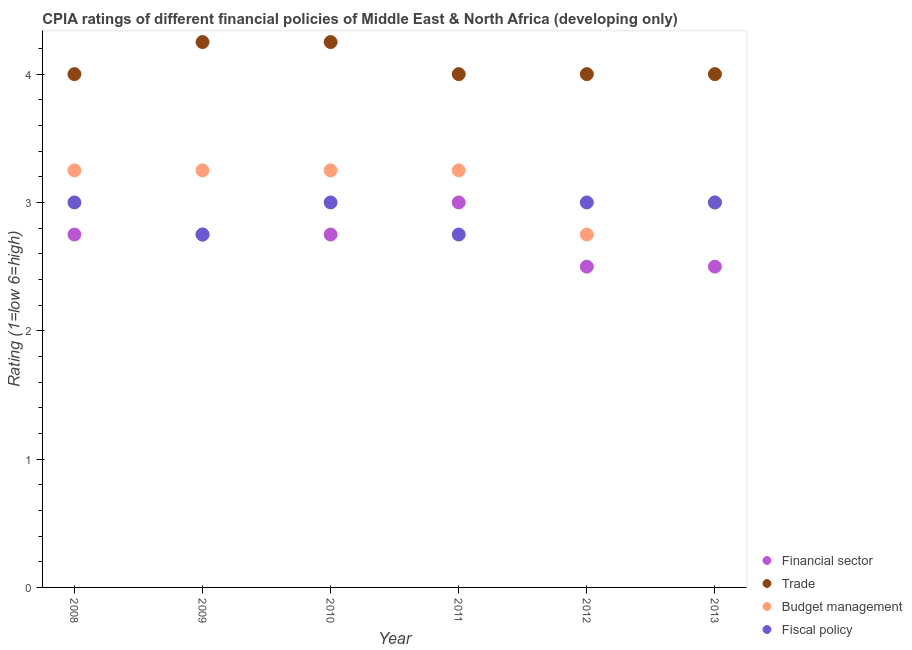Is the number of dotlines equal to the number of legend labels?
Offer a terse response. Yes. Across all years, what is the maximum cpia rating of trade?
Your answer should be compact. 4.25. Across all years, what is the minimum cpia rating of trade?
Your answer should be compact. 4. What is the total cpia rating of fiscal policy in the graph?
Provide a short and direct response. 17.5. What is the average cpia rating of financial sector per year?
Offer a terse response. 2.71. Is the cpia rating of budget management in 2009 less than that in 2013?
Offer a very short reply. No. Is the difference between the cpia rating of financial sector in 2009 and 2010 greater than the difference between the cpia rating of fiscal policy in 2009 and 2010?
Your response must be concise. Yes. In how many years, is the cpia rating of trade greater than the average cpia rating of trade taken over all years?
Make the answer very short. 2. Is the sum of the cpia rating of budget management in 2008 and 2012 greater than the maximum cpia rating of fiscal policy across all years?
Your response must be concise. Yes. Is it the case that in every year, the sum of the cpia rating of trade and cpia rating of fiscal policy is greater than the sum of cpia rating of budget management and cpia rating of financial sector?
Your answer should be very brief. Yes. Is it the case that in every year, the sum of the cpia rating of financial sector and cpia rating of trade is greater than the cpia rating of budget management?
Keep it short and to the point. Yes. How many dotlines are there?
Ensure brevity in your answer.  4. How many years are there in the graph?
Provide a succinct answer. 6. What is the difference between two consecutive major ticks on the Y-axis?
Offer a very short reply. 1. Are the values on the major ticks of Y-axis written in scientific E-notation?
Offer a very short reply. No. Does the graph contain any zero values?
Your response must be concise. No. How are the legend labels stacked?
Your answer should be very brief. Vertical. What is the title of the graph?
Give a very brief answer. CPIA ratings of different financial policies of Middle East & North Africa (developing only). Does "Periodicity assessment" appear as one of the legend labels in the graph?
Your answer should be compact. No. What is the label or title of the X-axis?
Keep it short and to the point. Year. What is the Rating (1=low 6=high) in Financial sector in 2008?
Give a very brief answer. 2.75. What is the Rating (1=low 6=high) in Trade in 2008?
Provide a short and direct response. 4. What is the Rating (1=low 6=high) of Budget management in 2008?
Offer a very short reply. 3.25. What is the Rating (1=low 6=high) of Fiscal policy in 2008?
Keep it short and to the point. 3. What is the Rating (1=low 6=high) of Financial sector in 2009?
Your answer should be compact. 2.75. What is the Rating (1=low 6=high) in Trade in 2009?
Offer a very short reply. 4.25. What is the Rating (1=low 6=high) of Fiscal policy in 2009?
Provide a short and direct response. 2.75. What is the Rating (1=low 6=high) of Financial sector in 2010?
Provide a succinct answer. 2.75. What is the Rating (1=low 6=high) in Trade in 2010?
Keep it short and to the point. 4.25. What is the Rating (1=low 6=high) of Financial sector in 2011?
Your response must be concise. 3. What is the Rating (1=low 6=high) of Budget management in 2011?
Make the answer very short. 3.25. What is the Rating (1=low 6=high) of Fiscal policy in 2011?
Give a very brief answer. 2.75. What is the Rating (1=low 6=high) in Trade in 2012?
Offer a very short reply. 4. What is the Rating (1=low 6=high) of Budget management in 2012?
Provide a short and direct response. 2.75. What is the Rating (1=low 6=high) of Fiscal policy in 2012?
Your answer should be compact. 3. What is the Rating (1=low 6=high) in Budget management in 2013?
Provide a succinct answer. 3. Across all years, what is the maximum Rating (1=low 6=high) of Trade?
Provide a short and direct response. 4.25. Across all years, what is the maximum Rating (1=low 6=high) of Fiscal policy?
Give a very brief answer. 3. Across all years, what is the minimum Rating (1=low 6=high) of Financial sector?
Provide a short and direct response. 2.5. Across all years, what is the minimum Rating (1=low 6=high) in Trade?
Give a very brief answer. 4. Across all years, what is the minimum Rating (1=low 6=high) of Budget management?
Keep it short and to the point. 2.75. Across all years, what is the minimum Rating (1=low 6=high) of Fiscal policy?
Provide a short and direct response. 2.75. What is the total Rating (1=low 6=high) in Financial sector in the graph?
Ensure brevity in your answer.  16.25. What is the total Rating (1=low 6=high) in Trade in the graph?
Offer a terse response. 24.5. What is the total Rating (1=low 6=high) of Budget management in the graph?
Keep it short and to the point. 18.75. What is the difference between the Rating (1=low 6=high) of Financial sector in 2008 and that in 2009?
Keep it short and to the point. 0. What is the difference between the Rating (1=low 6=high) of Trade in 2008 and that in 2009?
Your answer should be very brief. -0.25. What is the difference between the Rating (1=low 6=high) in Fiscal policy in 2008 and that in 2009?
Your response must be concise. 0.25. What is the difference between the Rating (1=low 6=high) of Trade in 2008 and that in 2010?
Offer a terse response. -0.25. What is the difference between the Rating (1=low 6=high) in Fiscal policy in 2008 and that in 2010?
Provide a succinct answer. 0. What is the difference between the Rating (1=low 6=high) of Financial sector in 2008 and that in 2011?
Provide a short and direct response. -0.25. What is the difference between the Rating (1=low 6=high) in Trade in 2008 and that in 2011?
Provide a short and direct response. 0. What is the difference between the Rating (1=low 6=high) in Budget management in 2008 and that in 2011?
Your answer should be very brief. 0. What is the difference between the Rating (1=low 6=high) of Budget management in 2008 and that in 2012?
Ensure brevity in your answer.  0.5. What is the difference between the Rating (1=low 6=high) of Financial sector in 2008 and that in 2013?
Offer a very short reply. 0.25. What is the difference between the Rating (1=low 6=high) in Fiscal policy in 2008 and that in 2013?
Your answer should be very brief. 0. What is the difference between the Rating (1=low 6=high) in Financial sector in 2009 and that in 2010?
Make the answer very short. 0. What is the difference between the Rating (1=low 6=high) in Budget management in 2009 and that in 2010?
Give a very brief answer. 0. What is the difference between the Rating (1=low 6=high) in Fiscal policy in 2009 and that in 2010?
Offer a very short reply. -0.25. What is the difference between the Rating (1=low 6=high) of Financial sector in 2009 and that in 2011?
Your answer should be compact. -0.25. What is the difference between the Rating (1=low 6=high) in Trade in 2009 and that in 2011?
Your answer should be very brief. 0.25. What is the difference between the Rating (1=low 6=high) in Trade in 2009 and that in 2012?
Your answer should be very brief. 0.25. What is the difference between the Rating (1=low 6=high) in Financial sector in 2009 and that in 2013?
Provide a succinct answer. 0.25. What is the difference between the Rating (1=low 6=high) in Trade in 2009 and that in 2013?
Make the answer very short. 0.25. What is the difference between the Rating (1=low 6=high) in Budget management in 2009 and that in 2013?
Provide a succinct answer. 0.25. What is the difference between the Rating (1=low 6=high) of Fiscal policy in 2009 and that in 2013?
Provide a short and direct response. -0.25. What is the difference between the Rating (1=low 6=high) of Financial sector in 2010 and that in 2011?
Provide a short and direct response. -0.25. What is the difference between the Rating (1=low 6=high) in Trade in 2010 and that in 2011?
Offer a terse response. 0.25. What is the difference between the Rating (1=low 6=high) in Financial sector in 2010 and that in 2012?
Provide a short and direct response. 0.25. What is the difference between the Rating (1=low 6=high) of Trade in 2010 and that in 2012?
Make the answer very short. 0.25. What is the difference between the Rating (1=low 6=high) in Budget management in 2010 and that in 2012?
Keep it short and to the point. 0.5. What is the difference between the Rating (1=low 6=high) in Budget management in 2010 and that in 2013?
Your answer should be very brief. 0.25. What is the difference between the Rating (1=low 6=high) of Fiscal policy in 2010 and that in 2013?
Your answer should be very brief. 0. What is the difference between the Rating (1=low 6=high) of Budget management in 2011 and that in 2012?
Provide a succinct answer. 0.5. What is the difference between the Rating (1=low 6=high) in Fiscal policy in 2011 and that in 2012?
Your answer should be compact. -0.25. What is the difference between the Rating (1=low 6=high) in Financial sector in 2011 and that in 2013?
Your answer should be very brief. 0.5. What is the difference between the Rating (1=low 6=high) of Trade in 2011 and that in 2013?
Your answer should be compact. 0. What is the difference between the Rating (1=low 6=high) in Budget management in 2011 and that in 2013?
Keep it short and to the point. 0.25. What is the difference between the Rating (1=low 6=high) of Financial sector in 2012 and that in 2013?
Provide a succinct answer. 0. What is the difference between the Rating (1=low 6=high) in Trade in 2012 and that in 2013?
Offer a very short reply. 0. What is the difference between the Rating (1=low 6=high) of Budget management in 2012 and that in 2013?
Provide a succinct answer. -0.25. What is the difference between the Rating (1=low 6=high) of Financial sector in 2008 and the Rating (1=low 6=high) of Trade in 2009?
Keep it short and to the point. -1.5. What is the difference between the Rating (1=low 6=high) in Trade in 2008 and the Rating (1=low 6=high) in Budget management in 2009?
Ensure brevity in your answer.  0.75. What is the difference between the Rating (1=low 6=high) of Trade in 2008 and the Rating (1=low 6=high) of Budget management in 2010?
Ensure brevity in your answer.  0.75. What is the difference between the Rating (1=low 6=high) of Financial sector in 2008 and the Rating (1=low 6=high) of Trade in 2011?
Offer a terse response. -1.25. What is the difference between the Rating (1=low 6=high) of Financial sector in 2008 and the Rating (1=low 6=high) of Budget management in 2011?
Offer a very short reply. -0.5. What is the difference between the Rating (1=low 6=high) in Budget management in 2008 and the Rating (1=low 6=high) in Fiscal policy in 2011?
Offer a very short reply. 0.5. What is the difference between the Rating (1=low 6=high) of Financial sector in 2008 and the Rating (1=low 6=high) of Trade in 2012?
Provide a short and direct response. -1.25. What is the difference between the Rating (1=low 6=high) of Financial sector in 2008 and the Rating (1=low 6=high) of Budget management in 2012?
Keep it short and to the point. 0. What is the difference between the Rating (1=low 6=high) of Financial sector in 2008 and the Rating (1=low 6=high) of Trade in 2013?
Your response must be concise. -1.25. What is the difference between the Rating (1=low 6=high) of Financial sector in 2008 and the Rating (1=low 6=high) of Budget management in 2013?
Offer a terse response. -0.25. What is the difference between the Rating (1=low 6=high) of Financial sector in 2009 and the Rating (1=low 6=high) of Trade in 2010?
Make the answer very short. -1.5. What is the difference between the Rating (1=low 6=high) in Financial sector in 2009 and the Rating (1=low 6=high) in Trade in 2011?
Your answer should be very brief. -1.25. What is the difference between the Rating (1=low 6=high) in Financial sector in 2009 and the Rating (1=low 6=high) in Fiscal policy in 2011?
Make the answer very short. 0. What is the difference between the Rating (1=low 6=high) of Trade in 2009 and the Rating (1=low 6=high) of Fiscal policy in 2011?
Provide a short and direct response. 1.5. What is the difference between the Rating (1=low 6=high) of Financial sector in 2009 and the Rating (1=low 6=high) of Trade in 2012?
Keep it short and to the point. -1.25. What is the difference between the Rating (1=low 6=high) of Financial sector in 2009 and the Rating (1=low 6=high) of Budget management in 2012?
Provide a short and direct response. 0. What is the difference between the Rating (1=low 6=high) of Trade in 2009 and the Rating (1=low 6=high) of Budget management in 2012?
Provide a short and direct response. 1.5. What is the difference between the Rating (1=low 6=high) in Budget management in 2009 and the Rating (1=low 6=high) in Fiscal policy in 2012?
Give a very brief answer. 0.25. What is the difference between the Rating (1=low 6=high) of Financial sector in 2009 and the Rating (1=low 6=high) of Trade in 2013?
Your response must be concise. -1.25. What is the difference between the Rating (1=low 6=high) in Financial sector in 2009 and the Rating (1=low 6=high) in Budget management in 2013?
Your response must be concise. -0.25. What is the difference between the Rating (1=low 6=high) in Budget management in 2009 and the Rating (1=low 6=high) in Fiscal policy in 2013?
Your answer should be compact. 0.25. What is the difference between the Rating (1=low 6=high) in Financial sector in 2010 and the Rating (1=low 6=high) in Trade in 2011?
Give a very brief answer. -1.25. What is the difference between the Rating (1=low 6=high) in Financial sector in 2010 and the Rating (1=low 6=high) in Budget management in 2011?
Your response must be concise. -0.5. What is the difference between the Rating (1=low 6=high) in Financial sector in 2010 and the Rating (1=low 6=high) in Fiscal policy in 2011?
Your answer should be very brief. 0. What is the difference between the Rating (1=low 6=high) of Trade in 2010 and the Rating (1=low 6=high) of Budget management in 2011?
Your answer should be compact. 1. What is the difference between the Rating (1=low 6=high) in Financial sector in 2010 and the Rating (1=low 6=high) in Trade in 2012?
Offer a terse response. -1.25. What is the difference between the Rating (1=low 6=high) of Trade in 2010 and the Rating (1=low 6=high) of Fiscal policy in 2012?
Make the answer very short. 1.25. What is the difference between the Rating (1=low 6=high) of Financial sector in 2010 and the Rating (1=low 6=high) of Trade in 2013?
Offer a very short reply. -1.25. What is the difference between the Rating (1=low 6=high) in Trade in 2010 and the Rating (1=low 6=high) in Fiscal policy in 2013?
Provide a short and direct response. 1.25. What is the difference between the Rating (1=low 6=high) of Budget management in 2010 and the Rating (1=low 6=high) of Fiscal policy in 2013?
Offer a terse response. 0.25. What is the difference between the Rating (1=low 6=high) of Financial sector in 2011 and the Rating (1=low 6=high) of Budget management in 2012?
Your answer should be compact. 0.25. What is the difference between the Rating (1=low 6=high) in Financial sector in 2011 and the Rating (1=low 6=high) in Fiscal policy in 2012?
Your answer should be very brief. 0. What is the difference between the Rating (1=low 6=high) in Budget management in 2011 and the Rating (1=low 6=high) in Fiscal policy in 2012?
Offer a very short reply. 0.25. What is the difference between the Rating (1=low 6=high) in Financial sector in 2011 and the Rating (1=low 6=high) in Trade in 2013?
Ensure brevity in your answer.  -1. What is the difference between the Rating (1=low 6=high) of Financial sector in 2011 and the Rating (1=low 6=high) of Budget management in 2013?
Provide a succinct answer. 0. What is the difference between the Rating (1=low 6=high) of Trade in 2011 and the Rating (1=low 6=high) of Budget management in 2013?
Ensure brevity in your answer.  1. What is the difference between the Rating (1=low 6=high) in Financial sector in 2012 and the Rating (1=low 6=high) in Budget management in 2013?
Offer a terse response. -0.5. What is the difference between the Rating (1=low 6=high) in Trade in 2012 and the Rating (1=low 6=high) in Fiscal policy in 2013?
Provide a succinct answer. 1. What is the average Rating (1=low 6=high) of Financial sector per year?
Offer a very short reply. 2.71. What is the average Rating (1=low 6=high) in Trade per year?
Make the answer very short. 4.08. What is the average Rating (1=low 6=high) of Budget management per year?
Your response must be concise. 3.12. What is the average Rating (1=low 6=high) of Fiscal policy per year?
Give a very brief answer. 2.92. In the year 2008, what is the difference between the Rating (1=low 6=high) in Financial sector and Rating (1=low 6=high) in Trade?
Your answer should be compact. -1.25. In the year 2008, what is the difference between the Rating (1=low 6=high) of Financial sector and Rating (1=low 6=high) of Budget management?
Provide a succinct answer. -0.5. In the year 2008, what is the difference between the Rating (1=low 6=high) in Trade and Rating (1=low 6=high) in Fiscal policy?
Provide a succinct answer. 1. In the year 2008, what is the difference between the Rating (1=low 6=high) of Budget management and Rating (1=low 6=high) of Fiscal policy?
Your answer should be compact. 0.25. In the year 2009, what is the difference between the Rating (1=low 6=high) of Financial sector and Rating (1=low 6=high) of Trade?
Make the answer very short. -1.5. In the year 2009, what is the difference between the Rating (1=low 6=high) of Financial sector and Rating (1=low 6=high) of Budget management?
Keep it short and to the point. -0.5. In the year 2009, what is the difference between the Rating (1=low 6=high) of Financial sector and Rating (1=low 6=high) of Fiscal policy?
Give a very brief answer. 0. In the year 2009, what is the difference between the Rating (1=low 6=high) in Budget management and Rating (1=low 6=high) in Fiscal policy?
Offer a very short reply. 0.5. In the year 2010, what is the difference between the Rating (1=low 6=high) in Financial sector and Rating (1=low 6=high) in Trade?
Your response must be concise. -1.5. In the year 2010, what is the difference between the Rating (1=low 6=high) in Financial sector and Rating (1=low 6=high) in Budget management?
Give a very brief answer. -0.5. In the year 2010, what is the difference between the Rating (1=low 6=high) in Financial sector and Rating (1=low 6=high) in Fiscal policy?
Your answer should be compact. -0.25. In the year 2010, what is the difference between the Rating (1=low 6=high) in Trade and Rating (1=low 6=high) in Budget management?
Keep it short and to the point. 1. In the year 2010, what is the difference between the Rating (1=low 6=high) in Trade and Rating (1=low 6=high) in Fiscal policy?
Provide a succinct answer. 1.25. In the year 2010, what is the difference between the Rating (1=low 6=high) of Budget management and Rating (1=low 6=high) of Fiscal policy?
Your response must be concise. 0.25. In the year 2011, what is the difference between the Rating (1=low 6=high) of Financial sector and Rating (1=low 6=high) of Trade?
Provide a short and direct response. -1. In the year 2011, what is the difference between the Rating (1=low 6=high) of Financial sector and Rating (1=low 6=high) of Fiscal policy?
Keep it short and to the point. 0.25. In the year 2011, what is the difference between the Rating (1=low 6=high) of Trade and Rating (1=low 6=high) of Budget management?
Ensure brevity in your answer.  0.75. In the year 2011, what is the difference between the Rating (1=low 6=high) of Budget management and Rating (1=low 6=high) of Fiscal policy?
Provide a succinct answer. 0.5. In the year 2012, what is the difference between the Rating (1=low 6=high) in Financial sector and Rating (1=low 6=high) in Trade?
Your response must be concise. -1.5. In the year 2012, what is the difference between the Rating (1=low 6=high) of Financial sector and Rating (1=low 6=high) of Budget management?
Your response must be concise. -0.25. In the year 2012, what is the difference between the Rating (1=low 6=high) in Trade and Rating (1=low 6=high) in Budget management?
Your answer should be very brief. 1.25. In the year 2012, what is the difference between the Rating (1=low 6=high) in Trade and Rating (1=low 6=high) in Fiscal policy?
Your answer should be compact. 1. In the year 2012, what is the difference between the Rating (1=low 6=high) of Budget management and Rating (1=low 6=high) of Fiscal policy?
Your answer should be compact. -0.25. In the year 2013, what is the difference between the Rating (1=low 6=high) of Financial sector and Rating (1=low 6=high) of Trade?
Offer a terse response. -1.5. In the year 2013, what is the difference between the Rating (1=low 6=high) in Financial sector and Rating (1=low 6=high) in Budget management?
Ensure brevity in your answer.  -0.5. In the year 2013, what is the difference between the Rating (1=low 6=high) in Financial sector and Rating (1=low 6=high) in Fiscal policy?
Offer a terse response. -0.5. In the year 2013, what is the difference between the Rating (1=low 6=high) in Trade and Rating (1=low 6=high) in Budget management?
Provide a short and direct response. 1. In the year 2013, what is the difference between the Rating (1=low 6=high) in Trade and Rating (1=low 6=high) in Fiscal policy?
Offer a terse response. 1. What is the ratio of the Rating (1=low 6=high) in Financial sector in 2008 to that in 2009?
Offer a very short reply. 1. What is the ratio of the Rating (1=low 6=high) in Trade in 2008 to that in 2009?
Your response must be concise. 0.94. What is the ratio of the Rating (1=low 6=high) in Trade in 2008 to that in 2010?
Keep it short and to the point. 0.94. What is the ratio of the Rating (1=low 6=high) in Fiscal policy in 2008 to that in 2010?
Ensure brevity in your answer.  1. What is the ratio of the Rating (1=low 6=high) of Trade in 2008 to that in 2011?
Your answer should be compact. 1. What is the ratio of the Rating (1=low 6=high) of Financial sector in 2008 to that in 2012?
Your answer should be very brief. 1.1. What is the ratio of the Rating (1=low 6=high) in Budget management in 2008 to that in 2012?
Your response must be concise. 1.18. What is the ratio of the Rating (1=low 6=high) of Fiscal policy in 2008 to that in 2012?
Provide a succinct answer. 1. What is the ratio of the Rating (1=low 6=high) of Trade in 2008 to that in 2013?
Your answer should be compact. 1. What is the ratio of the Rating (1=low 6=high) in Budget management in 2008 to that in 2013?
Keep it short and to the point. 1.08. What is the ratio of the Rating (1=low 6=high) of Fiscal policy in 2008 to that in 2013?
Give a very brief answer. 1. What is the ratio of the Rating (1=low 6=high) in Financial sector in 2009 to that in 2010?
Your response must be concise. 1. What is the ratio of the Rating (1=low 6=high) of Budget management in 2009 to that in 2010?
Your answer should be very brief. 1. What is the ratio of the Rating (1=low 6=high) of Financial sector in 2009 to that in 2011?
Your answer should be very brief. 0.92. What is the ratio of the Rating (1=low 6=high) of Trade in 2009 to that in 2011?
Give a very brief answer. 1.06. What is the ratio of the Rating (1=low 6=high) in Budget management in 2009 to that in 2011?
Make the answer very short. 1. What is the ratio of the Rating (1=low 6=high) of Budget management in 2009 to that in 2012?
Keep it short and to the point. 1.18. What is the ratio of the Rating (1=low 6=high) of Fiscal policy in 2009 to that in 2012?
Offer a very short reply. 0.92. What is the ratio of the Rating (1=low 6=high) in Financial sector in 2010 to that in 2011?
Provide a succinct answer. 0.92. What is the ratio of the Rating (1=low 6=high) of Trade in 2010 to that in 2011?
Your answer should be very brief. 1.06. What is the ratio of the Rating (1=low 6=high) of Fiscal policy in 2010 to that in 2011?
Ensure brevity in your answer.  1.09. What is the ratio of the Rating (1=low 6=high) in Financial sector in 2010 to that in 2012?
Keep it short and to the point. 1.1. What is the ratio of the Rating (1=low 6=high) of Budget management in 2010 to that in 2012?
Provide a short and direct response. 1.18. What is the ratio of the Rating (1=low 6=high) of Fiscal policy in 2010 to that in 2012?
Your response must be concise. 1. What is the ratio of the Rating (1=low 6=high) in Financial sector in 2010 to that in 2013?
Offer a very short reply. 1.1. What is the ratio of the Rating (1=low 6=high) in Trade in 2010 to that in 2013?
Keep it short and to the point. 1.06. What is the ratio of the Rating (1=low 6=high) in Trade in 2011 to that in 2012?
Your response must be concise. 1. What is the ratio of the Rating (1=low 6=high) of Budget management in 2011 to that in 2012?
Your response must be concise. 1.18. What is the ratio of the Rating (1=low 6=high) of Budget management in 2011 to that in 2013?
Provide a short and direct response. 1.08. What is the ratio of the Rating (1=low 6=high) of Fiscal policy in 2011 to that in 2013?
Provide a short and direct response. 0.92. What is the ratio of the Rating (1=low 6=high) of Budget management in 2012 to that in 2013?
Make the answer very short. 0.92. What is the difference between the highest and the second highest Rating (1=low 6=high) in Financial sector?
Your answer should be very brief. 0.25. What is the difference between the highest and the lowest Rating (1=low 6=high) in Trade?
Ensure brevity in your answer.  0.25. What is the difference between the highest and the lowest Rating (1=low 6=high) in Fiscal policy?
Make the answer very short. 0.25. 